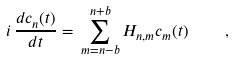<formula> <loc_0><loc_0><loc_500><loc_500>i \, \frac { d c _ { n } ( t ) } { d t } = \, \sum _ { m = n - b } ^ { n + b } H _ { n , m } c _ { m } ( t ) \quad ,</formula> 